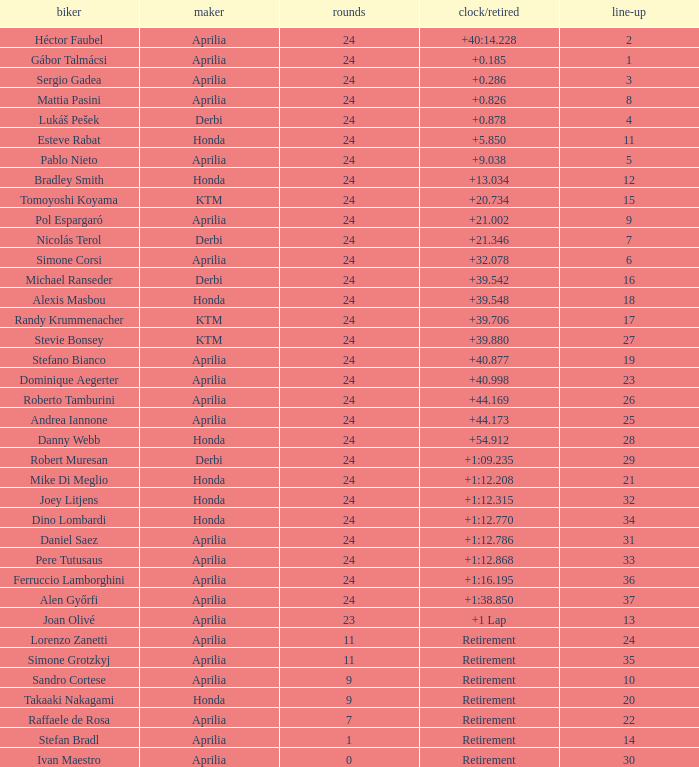How many grids correspond to more than 24 laps? None. 